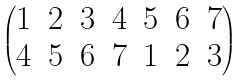Convert formula to latex. <formula><loc_0><loc_0><loc_500><loc_500>\begin{pmatrix} 1 & 2 & 3 & 4 & 5 & 6 & 7 \\ 4 & 5 & 6 & 7 & 1 & 2 & 3 \end{pmatrix}</formula> 